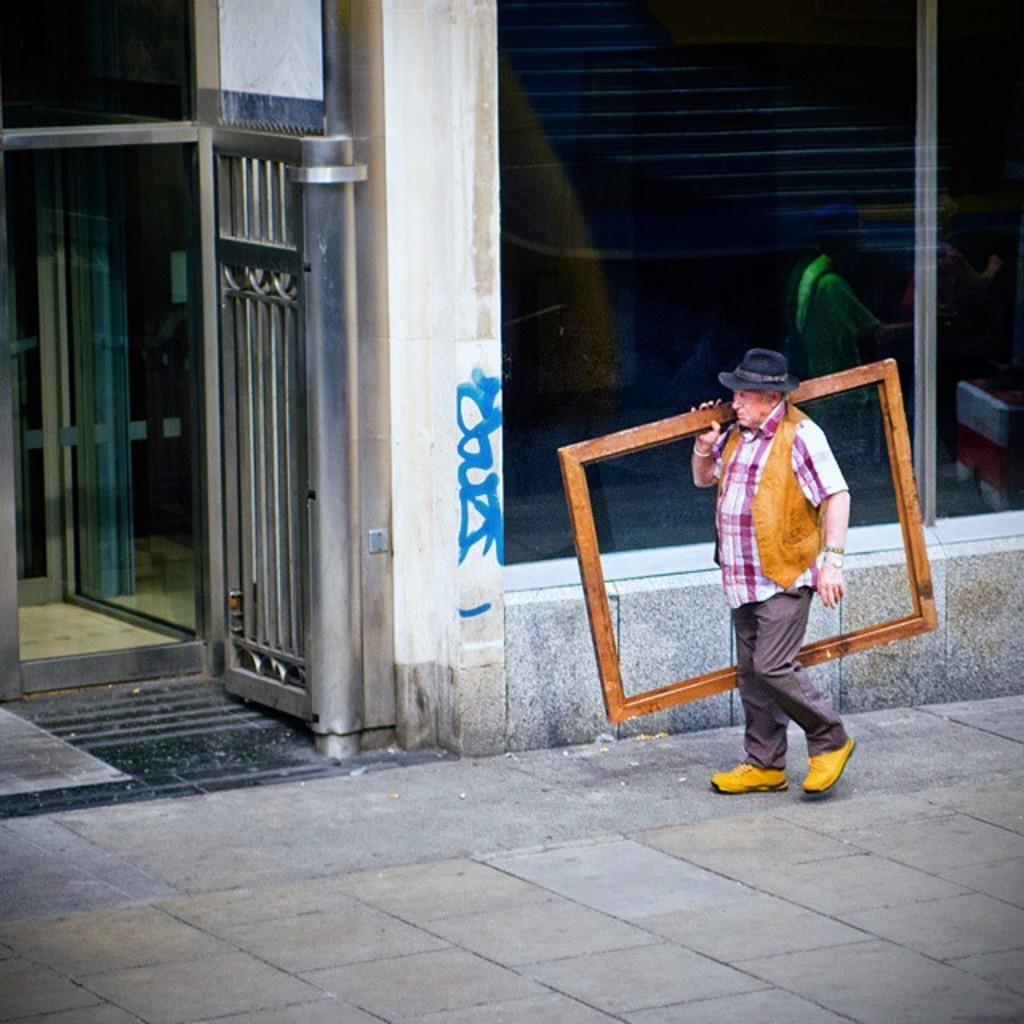What is the person in the image doing? The person is walking on the road. What is the person holding while walking? The person is holding a wooden structure. What can be seen in the background of the image? There is a building behind the person. Are there any architectural features near the building? Yes, there is a gate beside the building. What type of flowers can be seen growing in the plantation behind the person? There is no plantation or flowers visible in the image; it only shows a person walking on the road, holding a wooden structure, and a building with a gate in the background. 